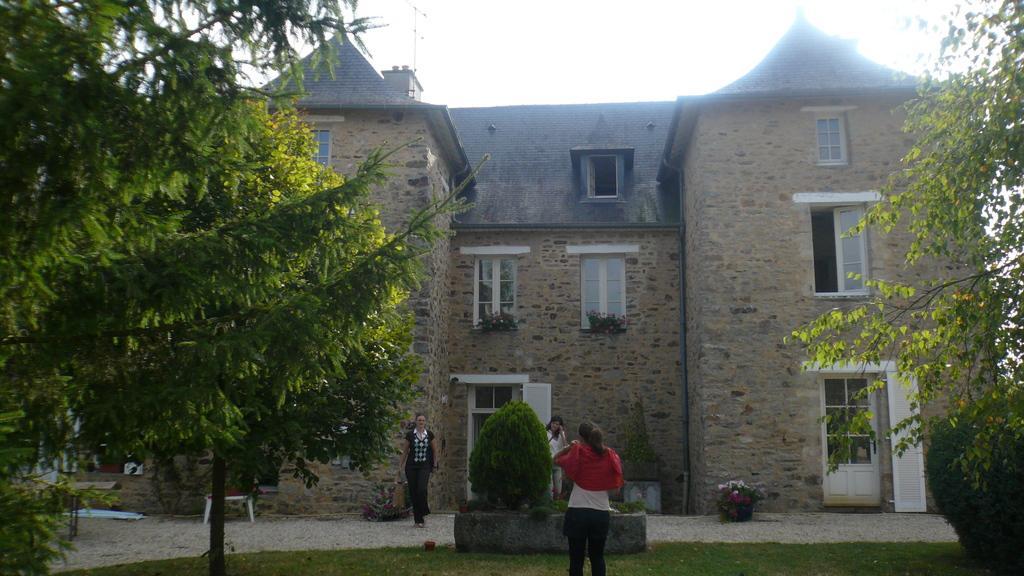Please provide a concise description of this image. In the image there is a castle in the back with many windows with three ladies standing in front of it, there are trees on either side of the grassland and above its sky. 